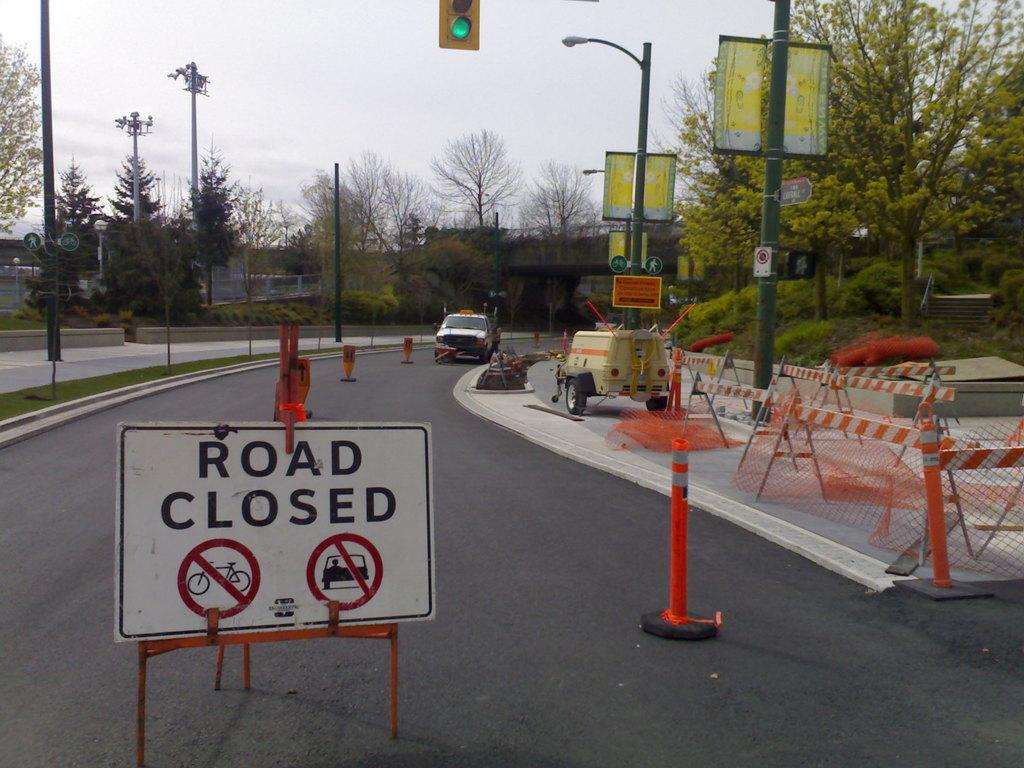<image>
Give a short and clear explanation of the subsequent image. A road closed sign is in the foreground while items used for working on the road is in the background. 